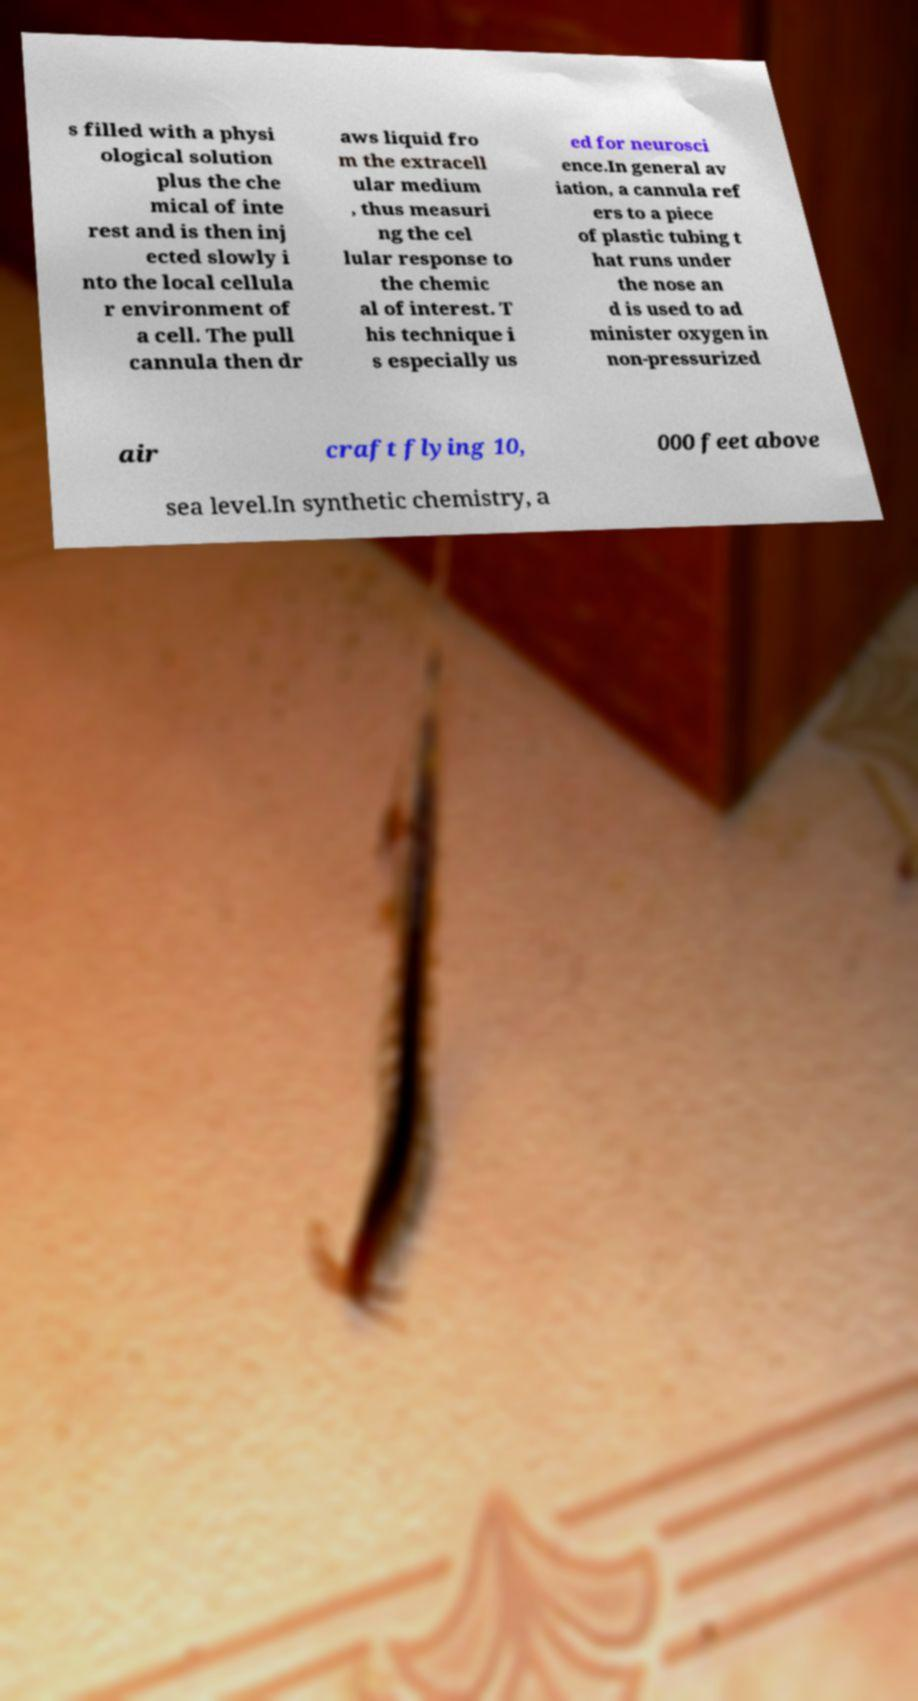Can you read and provide the text displayed in the image?This photo seems to have some interesting text. Can you extract and type it out for me? s filled with a physi ological solution plus the che mical of inte rest and is then inj ected slowly i nto the local cellula r environment of a cell. The pull cannula then dr aws liquid fro m the extracell ular medium , thus measuri ng the cel lular response to the chemic al of interest. T his technique i s especially us ed for neurosci ence.In general av iation, a cannula ref ers to a piece of plastic tubing t hat runs under the nose an d is used to ad minister oxygen in non-pressurized air craft flying 10, 000 feet above sea level.In synthetic chemistry, a 